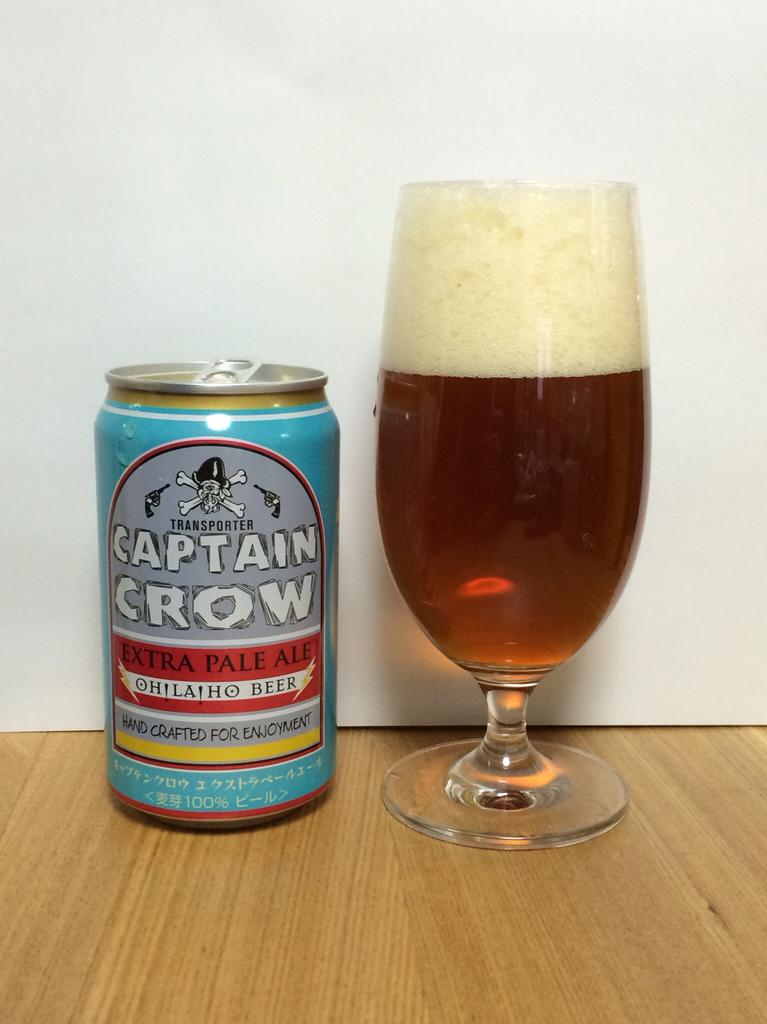<image>
Present a compact description of the photo's key features. A can of Captain Crow pale ale sits beside a foamy glass of beer. 